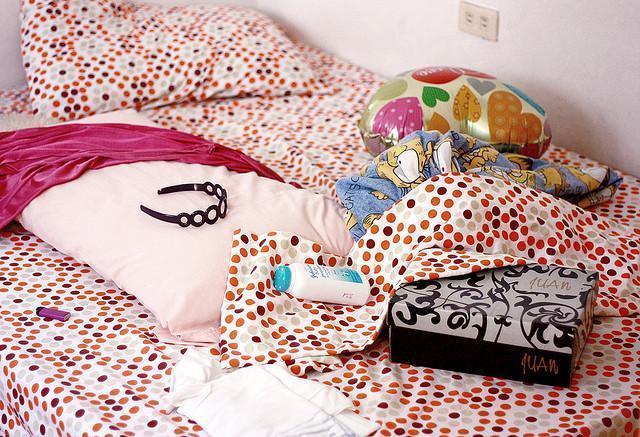How many bottles are there?
Give a very brief answer. 1. How many people are shown?
Give a very brief answer. 0. 